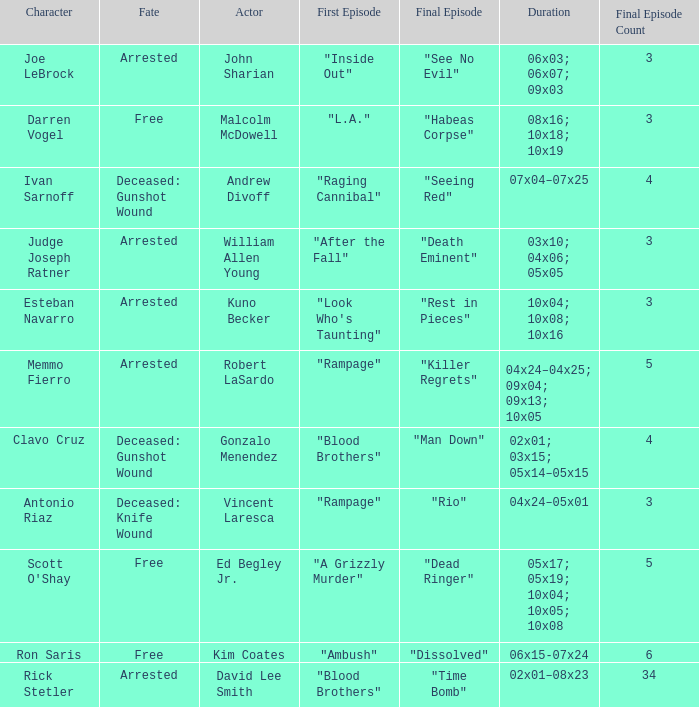Parse the full table. {'header': ['Character', 'Fate', 'Actor', 'First Episode', 'Final Episode', 'Duration', 'Final Episode Count'], 'rows': [['Joe LeBrock', 'Arrested', 'John Sharian', '"Inside Out"', '"See No Evil"', '06x03; 06x07; 09x03', '3'], ['Darren Vogel', 'Free', 'Malcolm McDowell', '"L.A."', '"Habeas Corpse"', '08x16; 10x18; 10x19', '3'], ['Ivan Sarnoff', 'Deceased: Gunshot Wound', 'Andrew Divoff', '"Raging Cannibal"', '"Seeing Red"', '07x04–07x25', '4'], ['Judge Joseph Ratner', 'Arrested', 'William Allen Young', '"After the Fall"', '"Death Eminent"', '03x10; 04x06; 05x05', '3'], ['Esteban Navarro', 'Arrested', 'Kuno Becker', '"Look Who\'s Taunting"', '"Rest in Pieces"', '10x04; 10x08; 10x16', '3'], ['Memmo Fierro', 'Arrested', 'Robert LaSardo', '"Rampage"', '"Killer Regrets"', '04x24–04x25; 09x04; 09x13; 10x05', '5'], ['Clavo Cruz', 'Deceased: Gunshot Wound', 'Gonzalo Menendez', '"Blood Brothers"', '"Man Down"', '02x01; 03x15; 05x14–05x15', '4'], ['Antonio Riaz', 'Deceased: Knife Wound', 'Vincent Laresca', '"Rampage"', '"Rio"', '04x24–05x01', '3'], ["Scott O'Shay", 'Free', 'Ed Begley Jr.', '"A Grizzly Murder"', '"Dead Ringer"', '05x17; 05x19; 10x04; 10x05; 10x08', '5'], ['Ron Saris', 'Free', 'Kim Coates', '"Ambush"', '"Dissolved"', '06x15-07x24', '6'], ['Rick Stetler', 'Arrested', 'David Lee Smith', '"Blood Brothers"', '"Time Bomb"', '02x01–08x23', '34']]} What's the first epbeingode with final epbeingode being "rio" "Rampage". 